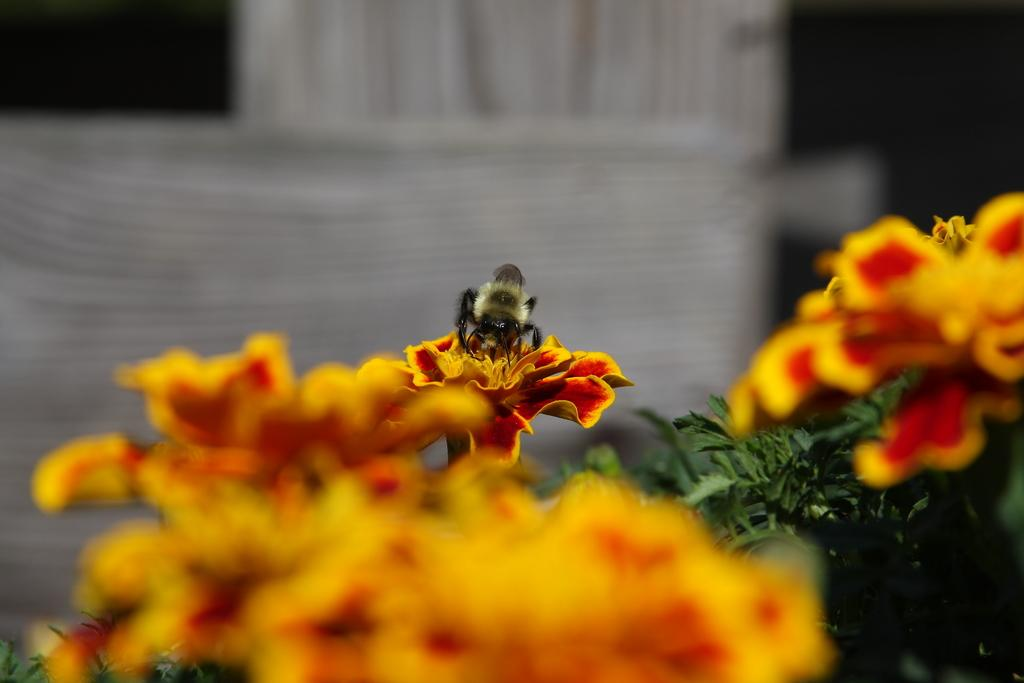What type of living organisms can be seen in the image? There are flowers and a bee in the image. Where is the bee located in relation to the flowers? The bee is on one of the flowers in the image. What type of surface is visible in the background of the image? There is a wooden surface in the background of the image. How would you describe the background of the image? The background is blurred. What type of basin is visible in the image? There is no basin present in the image. Can you describe the bee's tongue in the image? The image does not show the bee's tongue, so it cannot be described. 